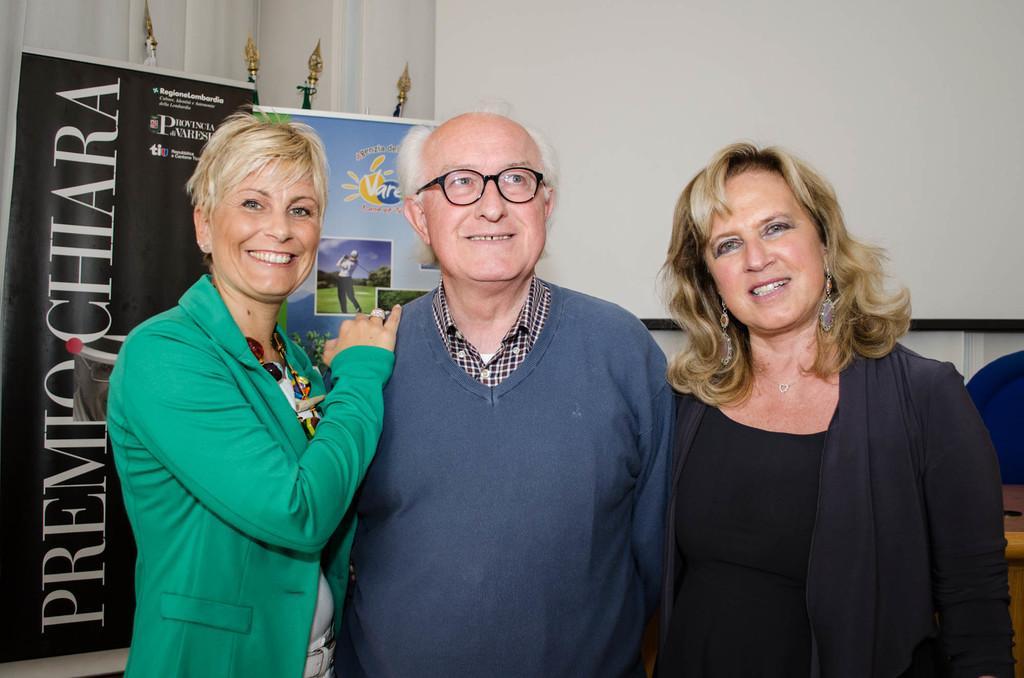Please provide a concise description of this image. In this picture there are people standing and smiling. In the background of the image we can see banners and objects. 